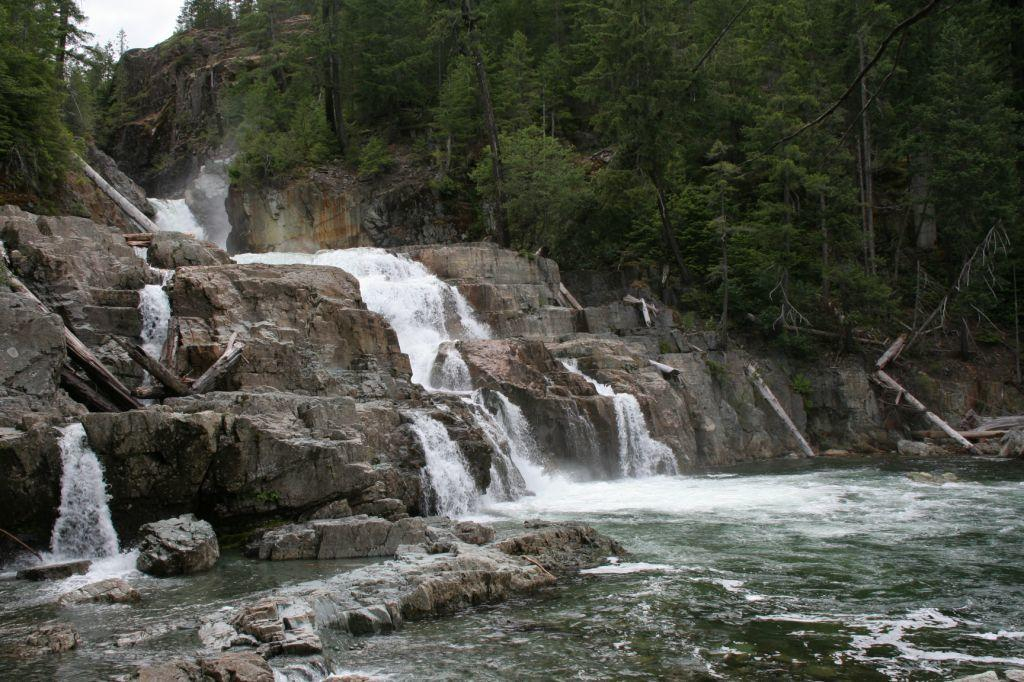What type of natural features can be seen in the image? There are trees, a waterfall, and rocks in the image. Can you describe the water feature in the image? There is a waterfall in the image. What is the color of the sky in the image? The sky appears to be white in color. What type of animal can be seen interacting with the rocks in the image? There are no animals present in the image; it only features trees, a waterfall, rocks, and a white sky. How is the friction between the water and rocks distributed in the image? There is no need to discuss friction between the water and rocks in the image, as the focus is on describing the natural features present. 